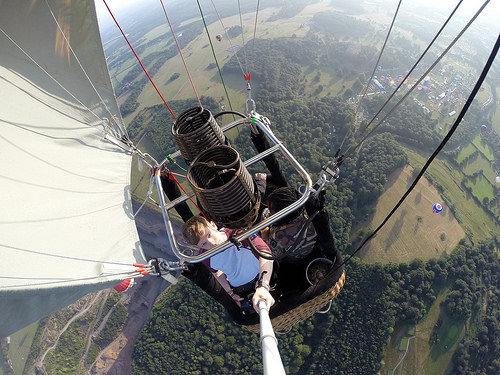<image>
Is there a man under the pole? Yes. The man is positioned underneath the pole, with the pole above it in the vertical space. 